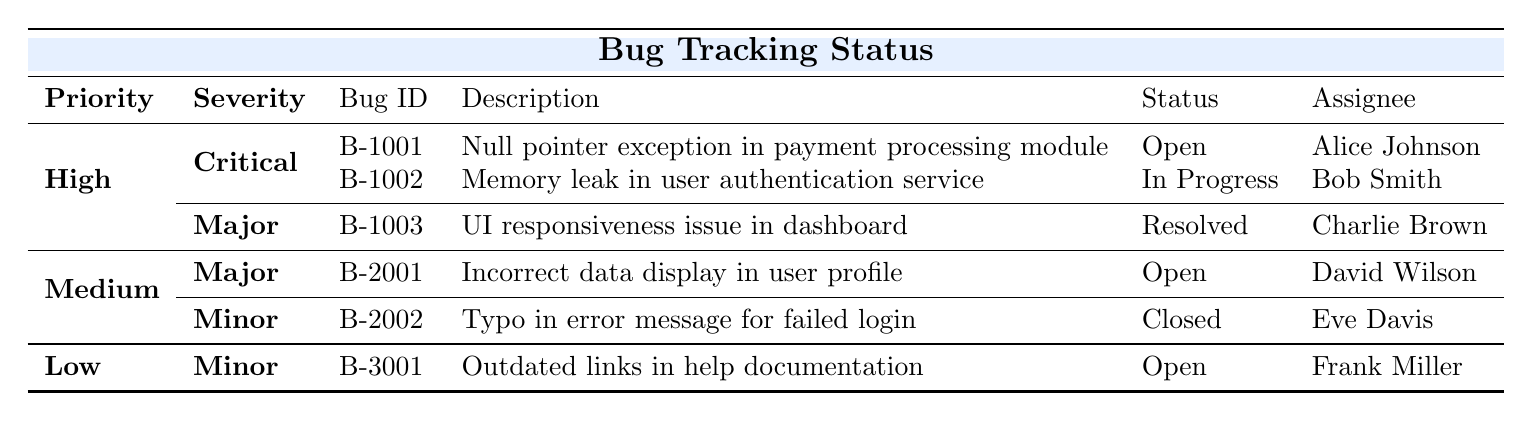What is the status of bug B-1001? The status of bug B-1001 is listed as 'Open' in the table.
Answer: Open How many critical bugs are currently open? The table shows two critical bugs: B-1001 and B-2001. Only B-1001 is currently open. Thus, there is 1 open critical bug.
Answer: 1 Who is assigned to the bug with ID B-2002? The table indicates that bug B-2002 is assigned to Eve Davis.
Answer: Eve Davis Are there any bugs with a priority level of Low that are currently resolved? There are no bugs listed under Low priority, which means there are no resolved bugs for this level.
Answer: No What is the total number of bugs listed under Medium priority? The total number of bugs listed under Medium is 2: B-2001 and B-2002.
Answer: 2 Which bug is assigned to David Wilson, and what is its severity? David Wilson is assigned to bug B-2001, which has a severity of Major as noted in the table.
Answer: B-2001, Major Is there any bug with a status of 'Resolved'? Yes, the table shows that bug B-1003 has a status of 'Resolved'.
Answer: Yes What is the date reported for the bug that has a status of 'In Progress'? The bug with ID B-1002 is In Progress and it was reported on 2023-10-02.
Answer: 2023-10-02 How many total open bugs are there in the High priority category? Within the High priority category, there are two open bugs: B-1001 (Critical) and none for Major. Therefore, there are a total of 2 open bugs.
Answer: 2 